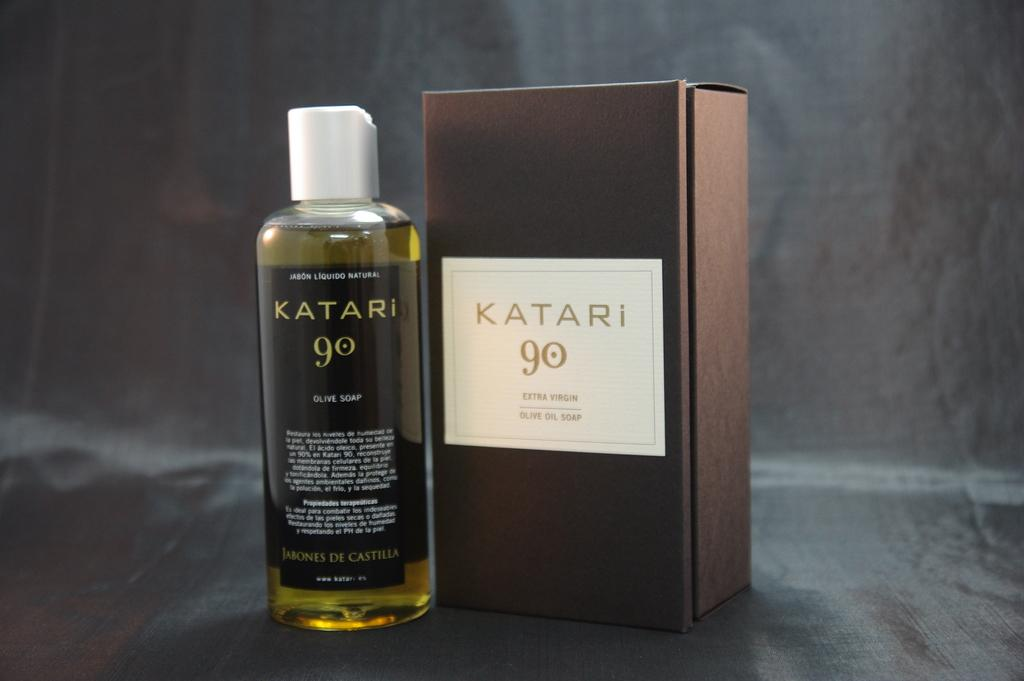<image>
Share a concise interpretation of the image provided. A gray background with a bottle of perfume labeled Katari 90 sitting next to it's  box 